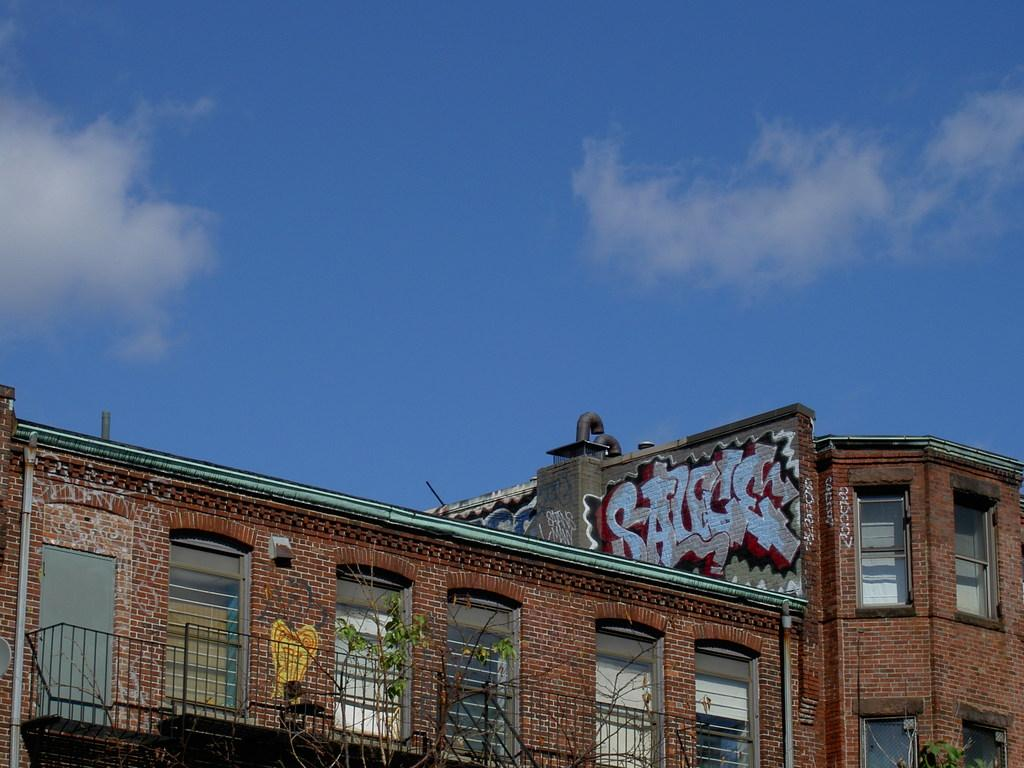What type of natural elements can be seen in the image? There are trees in the image. What type of man-made structure is present in the image? There is a building in the image. What architectural feature can be seen on the building? There are windows in the image. What type of artistic expression is present on the building? There is graffiti on a wall in the image. What is visible in the background of the image? The sky is visible in the background of the image. What type of weather can be inferred from the sky? There are clouds in the sky, suggesting a partly cloudy day. What type of coat is the committee wearing in the image? There is no committee or coat present in the image. What type of organization is responsible for the graffiti in the image? The facts provided do not give information about the organization responsible for the graffiti. 